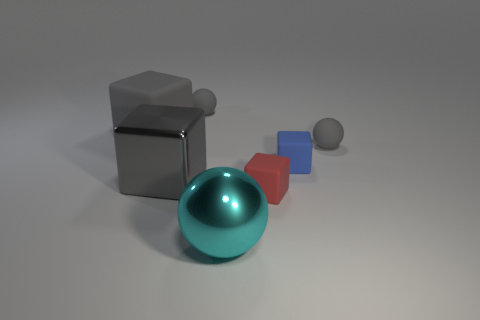Subtract all gray spheres. How many were subtracted if there are1gray spheres left? 1 Add 3 gray blocks. How many objects exist? 10 Subtract all green blocks. Subtract all gray cylinders. How many blocks are left? 4 Subtract all cubes. How many objects are left? 3 Add 1 gray matte spheres. How many gray matte spheres are left? 3 Add 3 tiny red metallic spheres. How many tiny red metallic spheres exist? 3 Subtract 0 yellow blocks. How many objects are left? 7 Subtract all rubber blocks. Subtract all small purple cylinders. How many objects are left? 4 